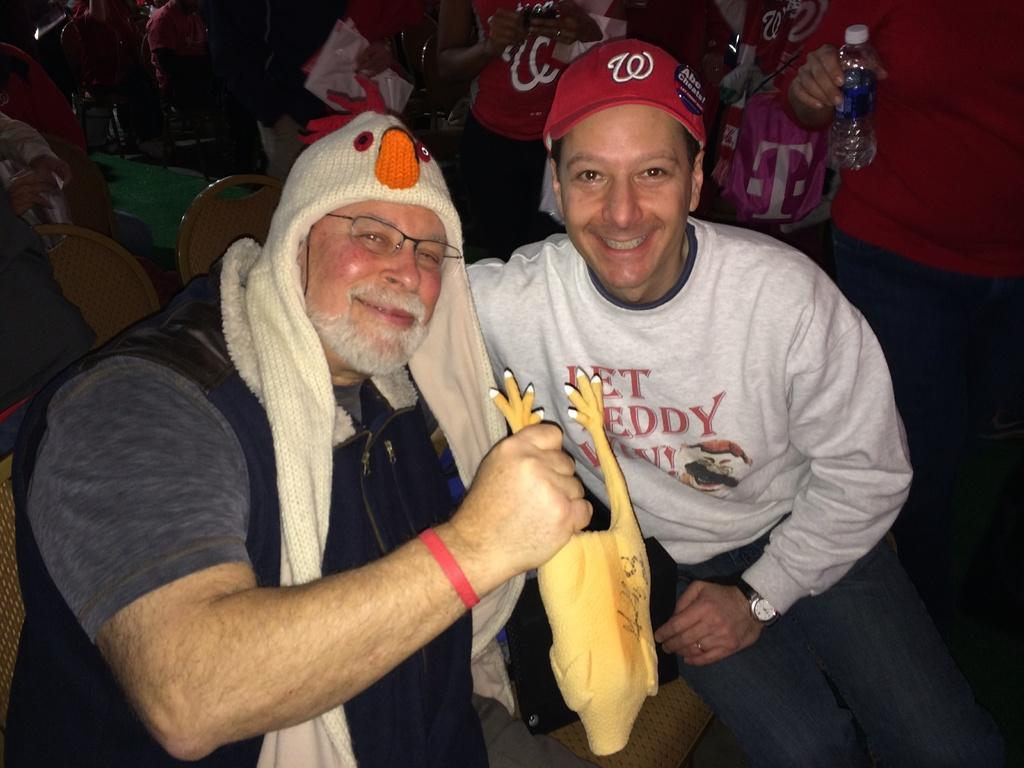<image>
Write a terse but informative summary of the picture. A man wearing a W hat poses for a photo with a man holding a chicken. 